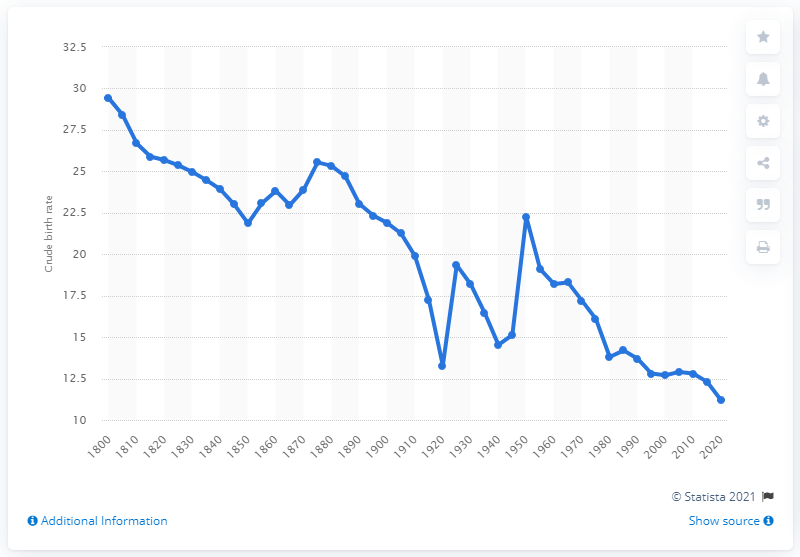Specify some key components in this picture. In the year 1800, the crude birth rate in France was 29.4. According to projections, the crude birth rate of France is expected to reach 11.2 in 2020. In the year 1800, the crude birth rate in France was 29.4. 